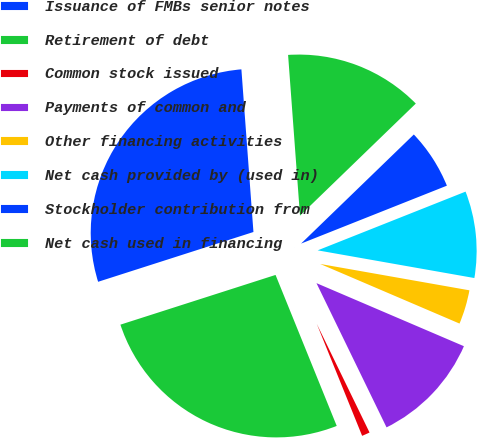Convert chart to OTSL. <chart><loc_0><loc_0><loc_500><loc_500><pie_chart><fcel>Issuance of FMBs senior notes<fcel>Retirement of debt<fcel>Common stock issued<fcel>Payments of common and<fcel>Other financing activities<fcel>Net cash provided by (used in)<fcel>Stockholder contribution from<fcel>Net cash used in financing<nl><fcel>28.76%<fcel>26.19%<fcel>1.07%<fcel>11.37%<fcel>3.65%<fcel>8.8%<fcel>6.22%<fcel>13.94%<nl></chart> 